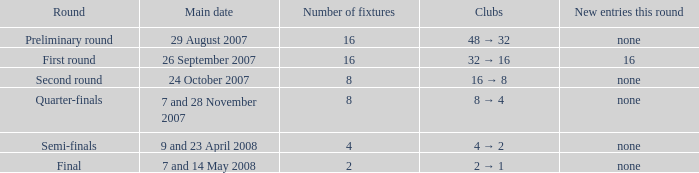What is the Round when the number of fixtures is more than 2, and the Main date of 7 and 28 november 2007? Quarter-finals. 